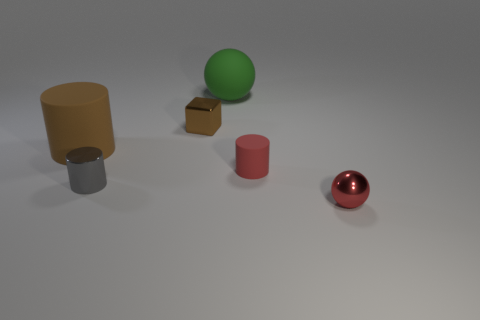How many other red things are the same shape as the small rubber thing?
Offer a very short reply. 0. What number of large objects are blue matte cylinders or metallic spheres?
Ensure brevity in your answer.  0. There is a metallic thing that is in front of the gray metallic thing; is its color the same as the small matte cylinder?
Your answer should be compact. Yes. There is a ball that is in front of the tiny red rubber cylinder; is its color the same as the cylinder that is right of the large green matte thing?
Your response must be concise. Yes. Are there any big brown cubes that have the same material as the gray cylinder?
Your answer should be very brief. No. How many purple objects are blocks or metallic spheres?
Offer a terse response. 0. Is the number of metallic cubes that are in front of the red rubber object greater than the number of gray matte things?
Make the answer very short. No. Is the brown cylinder the same size as the cube?
Keep it short and to the point. No. The cube that is made of the same material as the small red sphere is what color?
Keep it short and to the point. Brown. What shape is the metallic object that is the same color as the tiny matte thing?
Provide a succinct answer. Sphere. 